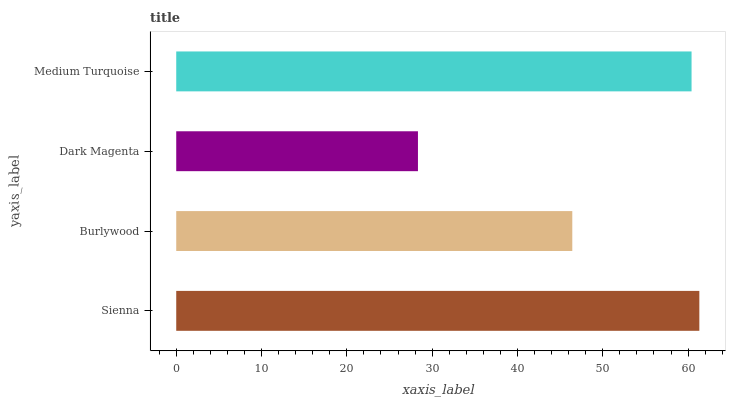Is Dark Magenta the minimum?
Answer yes or no. Yes. Is Sienna the maximum?
Answer yes or no. Yes. Is Burlywood the minimum?
Answer yes or no. No. Is Burlywood the maximum?
Answer yes or no. No. Is Sienna greater than Burlywood?
Answer yes or no. Yes. Is Burlywood less than Sienna?
Answer yes or no. Yes. Is Burlywood greater than Sienna?
Answer yes or no. No. Is Sienna less than Burlywood?
Answer yes or no. No. Is Medium Turquoise the high median?
Answer yes or no. Yes. Is Burlywood the low median?
Answer yes or no. Yes. Is Burlywood the high median?
Answer yes or no. No. Is Medium Turquoise the low median?
Answer yes or no. No. 